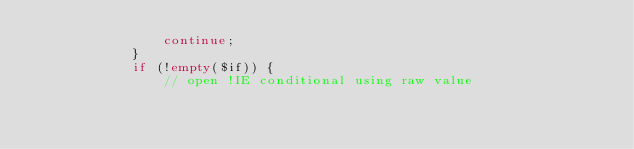Convert code to text. <code><loc_0><loc_0><loc_500><loc_500><_PHP_>                continue;
            }
            if (!empty($if)) {
                // open !IE conditional using raw value</code> 